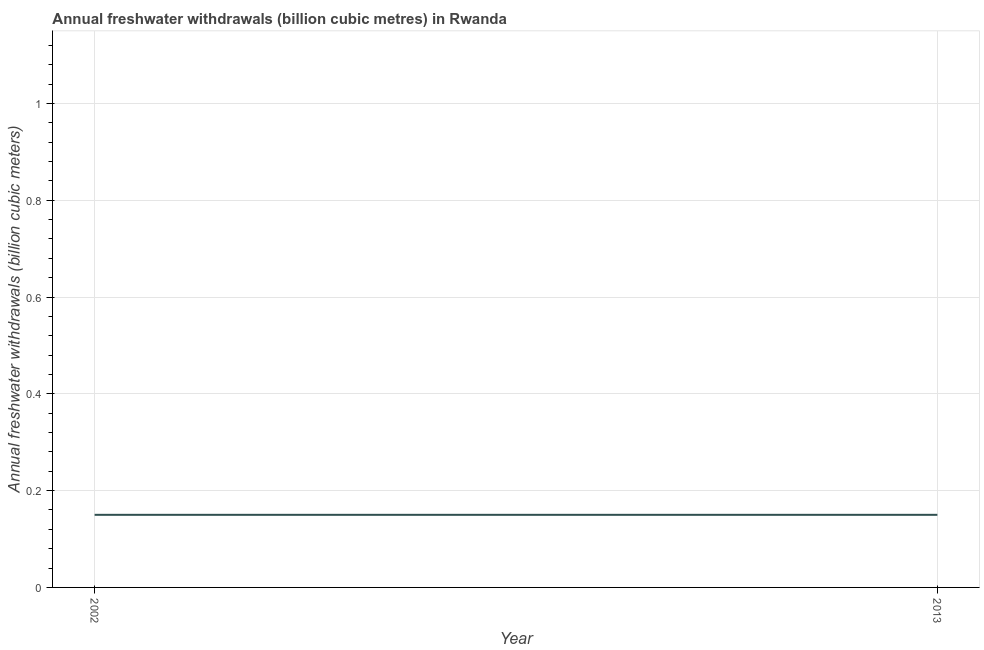What is the annual freshwater withdrawals in 2002?
Give a very brief answer. 0.15. Across all years, what is the maximum annual freshwater withdrawals?
Make the answer very short. 0.15. Across all years, what is the minimum annual freshwater withdrawals?
Provide a succinct answer. 0.15. In which year was the annual freshwater withdrawals minimum?
Offer a terse response. 2002. What is the sum of the annual freshwater withdrawals?
Provide a short and direct response. 0.3. What is the difference between the annual freshwater withdrawals in 2002 and 2013?
Your answer should be very brief. 0. What is the average annual freshwater withdrawals per year?
Provide a succinct answer. 0.15. Is the annual freshwater withdrawals in 2002 less than that in 2013?
Your response must be concise. No. How many lines are there?
Ensure brevity in your answer.  1. How many years are there in the graph?
Make the answer very short. 2. Does the graph contain grids?
Provide a short and direct response. Yes. What is the title of the graph?
Your answer should be very brief. Annual freshwater withdrawals (billion cubic metres) in Rwanda. What is the label or title of the Y-axis?
Your answer should be compact. Annual freshwater withdrawals (billion cubic meters). What is the Annual freshwater withdrawals (billion cubic meters) in 2002?
Ensure brevity in your answer.  0.15. What is the Annual freshwater withdrawals (billion cubic meters) in 2013?
Provide a succinct answer. 0.15. What is the difference between the Annual freshwater withdrawals (billion cubic meters) in 2002 and 2013?
Offer a terse response. 0. What is the ratio of the Annual freshwater withdrawals (billion cubic meters) in 2002 to that in 2013?
Provide a short and direct response. 1. 